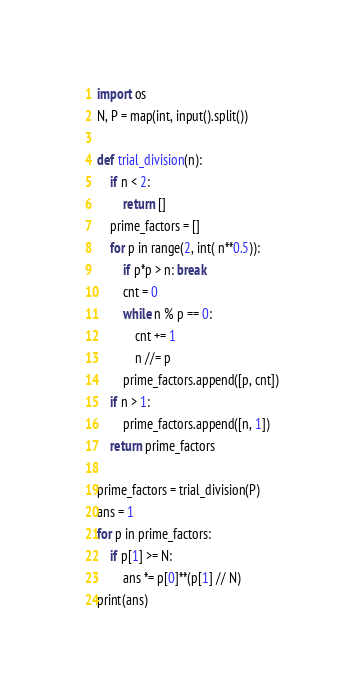<code> <loc_0><loc_0><loc_500><loc_500><_Python_>import os
N, P = map(int, input().split())

def trial_division(n):
    if n < 2:
        return []
    prime_factors = []
    for p in range(2, int( n**0.5)):
        if p*p > n: break
        cnt = 0
        while n % p == 0:
            cnt += 1
            n //= p
        prime_factors.append([p, cnt])
    if n > 1:
        prime_factors.append([n, 1])
    return prime_factors

prime_factors = trial_division(P)
ans = 1
for p in prime_factors:
    if p[1] >= N:
        ans *= p[0]**(p[1] // N)
print(ans)</code> 